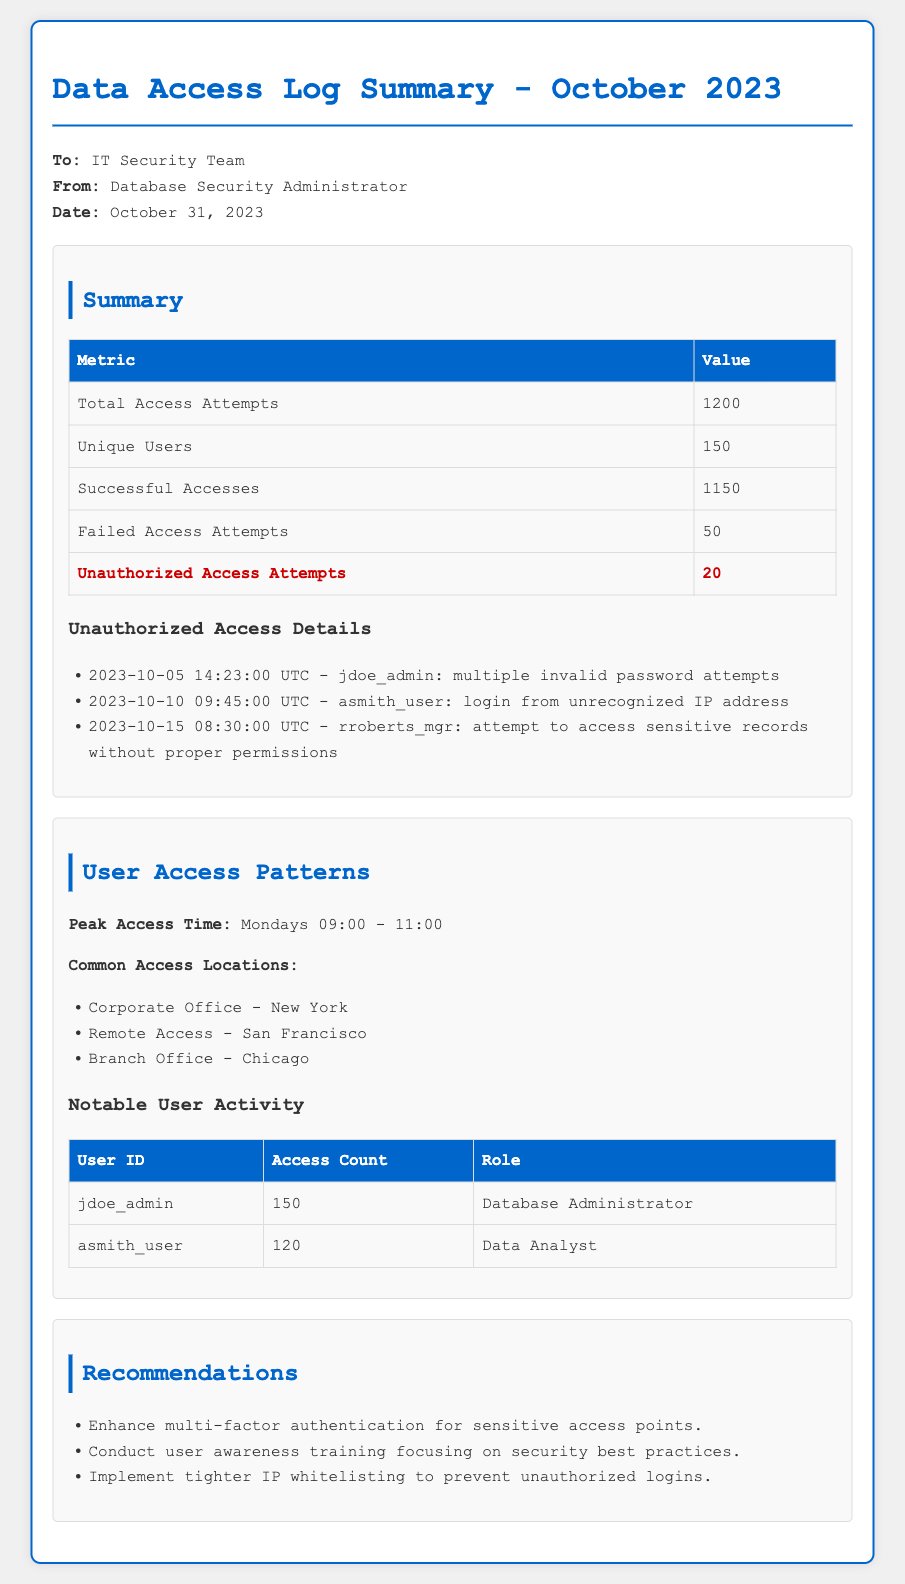What is the total number of access attempts? The total number of access attempts is specified in the summary table under "Total Access Attempts."
Answer: 1200 How many unique users accessed the database? The number of unique users is listed under "Unique Users" in the summary table.
Answer: 150 What role does the user 'jdoe_admin' have? The role of 'jdoe_admin' is detailed in the notable user activity table under "Role."
Answer: Database Administrator What was the peak access time? The peak access time is stated in the User Access Patterns section as "Peak Access Time."
Answer: Mondays 09:00 - 11:00 How many unauthorized access attempts were reported? The document specifies the count of unauthorized access attempts in the summary section.
Answer: 20 What security recommendation is given regarding access points? The recommendations section includes various strategies to enhance security, specifically for sensitive access points.
Answer: Enhance multi-factor authentication What was an instance of unauthorized access? An example of unauthorized access is provided in the Unauthorized Access Details list.
Answer: 2023-10-05 14:23:00 UTC - jdoe_admin: multiple invalid password attempts What was the access count for 'asmith_user'? The access count for 'asmith_user' is noted in the notable user activity table under "Access Count."
Answer: 120 What is a common access location? Common access locations are mentioned in the User Access Patterns section, listing three locations.
Answer: Corporate Office - New York 